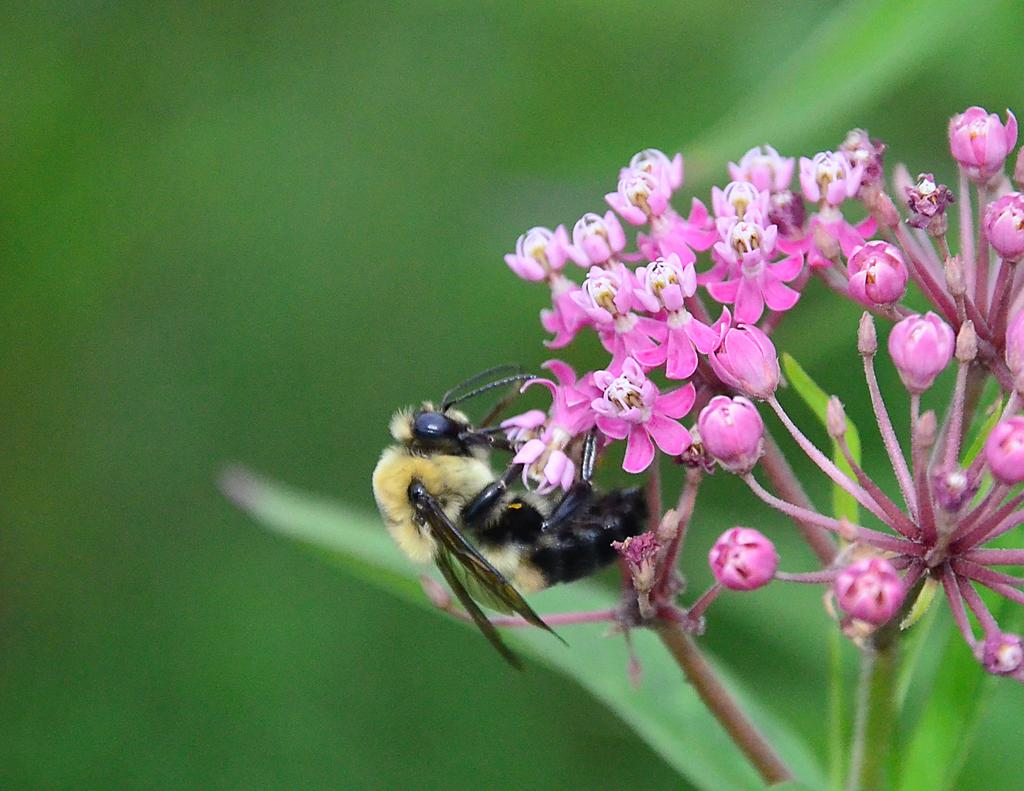What is present in the image? There is a bee in the image. Where is the bee located? The bee is on a flower. What type of authority does the bee have in the image? There is no indication of authority in the image, as it features a bee on a flower. Is the bee playing volleyball in the image? No, the bee is not playing volleyball in the image; it is on a flower. 